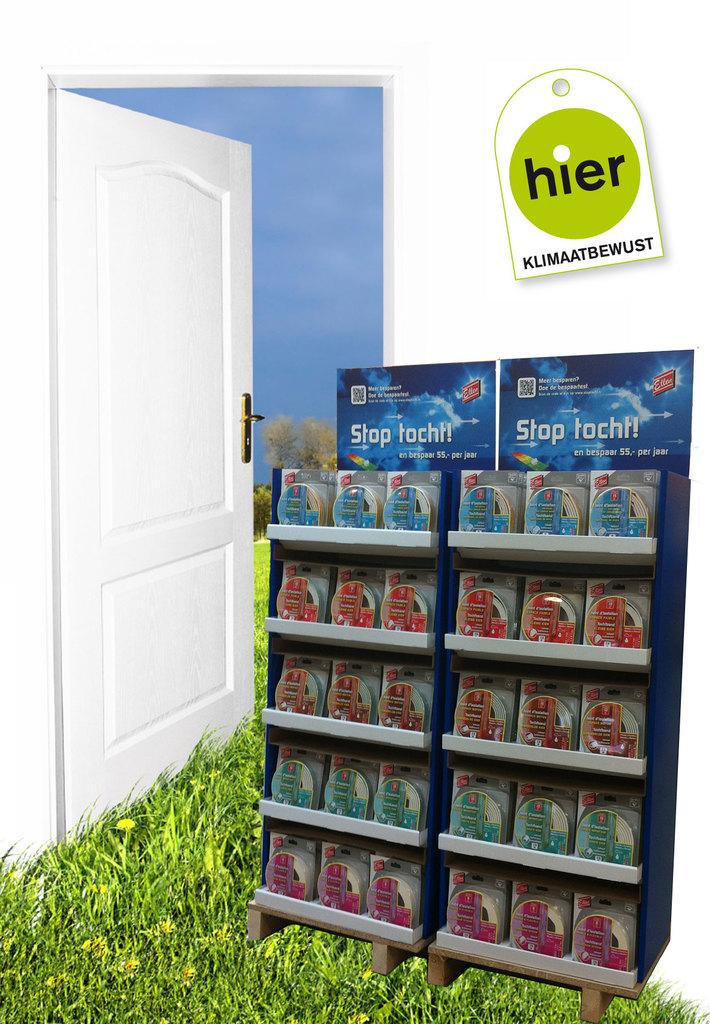What is arranged in the image? There are sachets arranged in the image. What structure can be seen in the image? There is a door in the image. What color is the wall visible in the background of the image? There is a white wall in the background of the image. What type of egg is being used as an apparatus in the image? There is no egg or apparatus present in the image. 